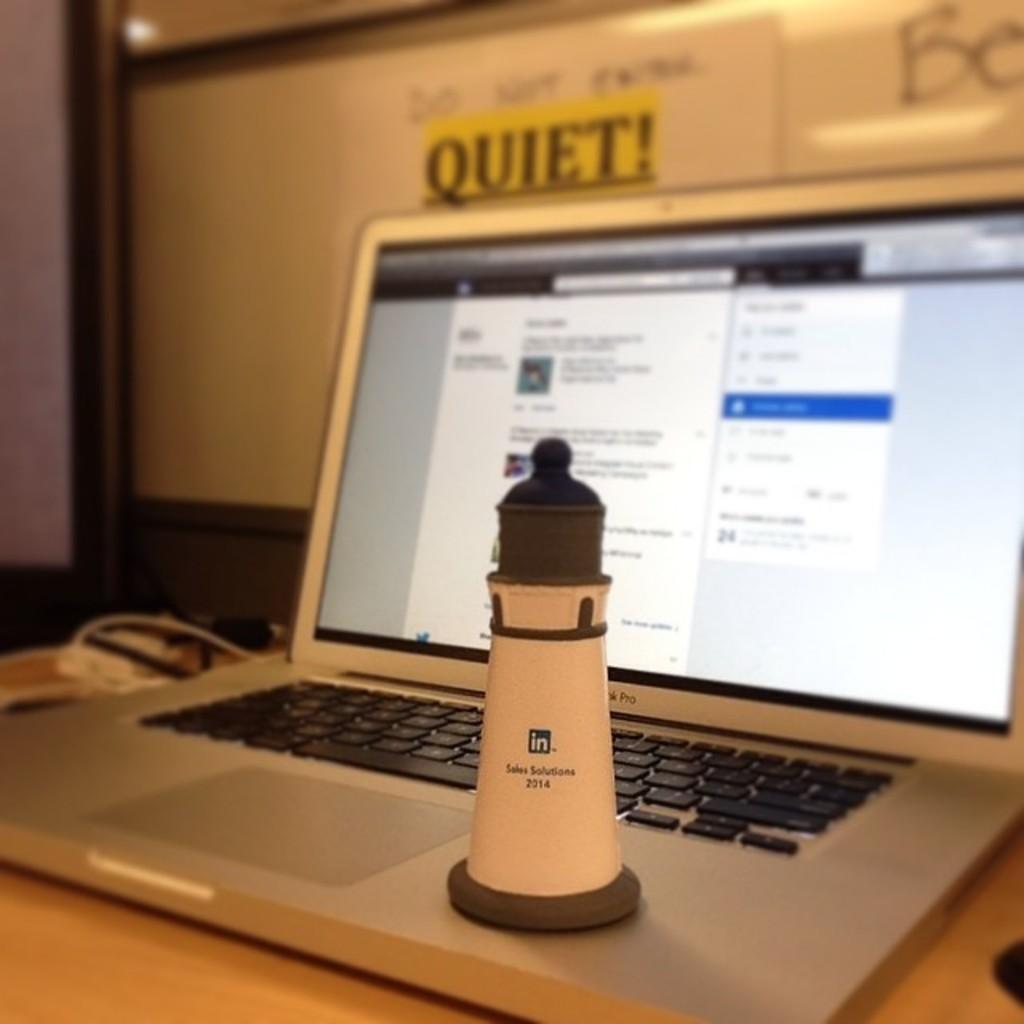Do we need to be quiet?
Offer a terse response. Yes. What year is written on the light house?
Provide a succinct answer. 2014. 